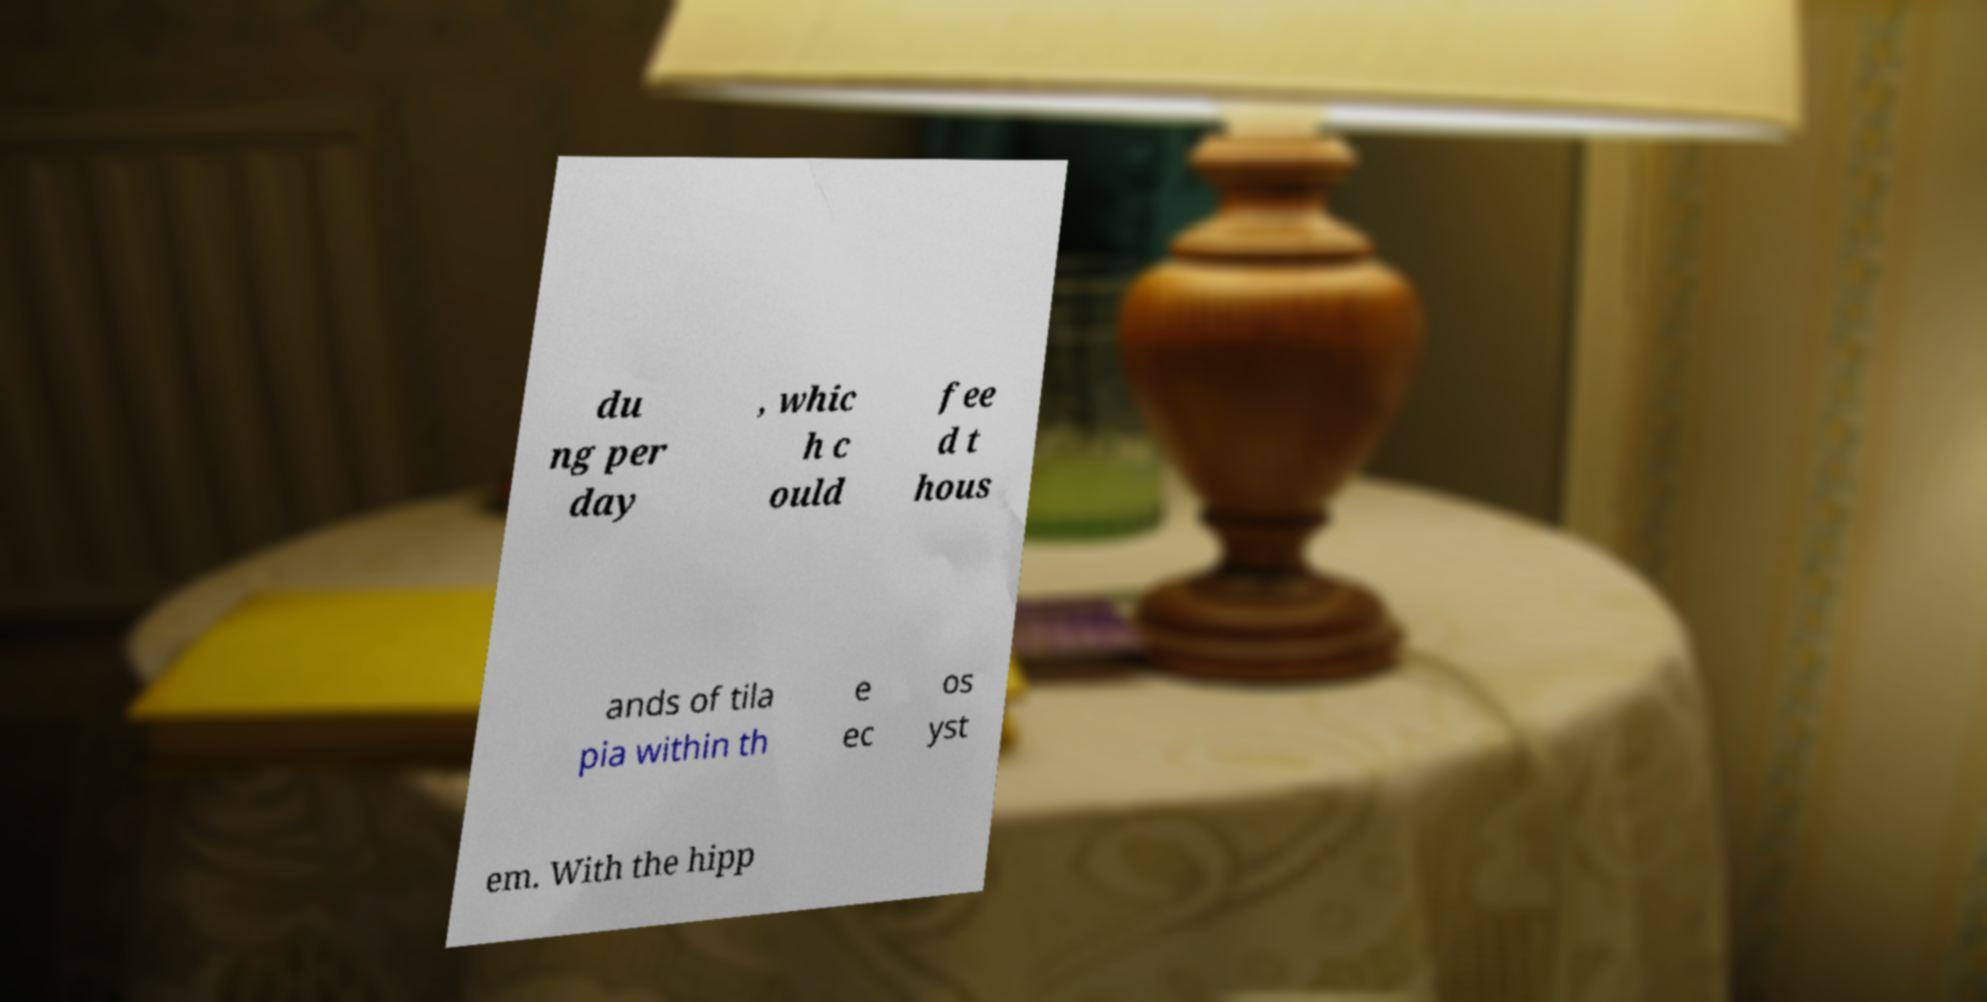Can you accurately transcribe the text from the provided image for me? du ng per day , whic h c ould fee d t hous ands of tila pia within th e ec os yst em. With the hipp 